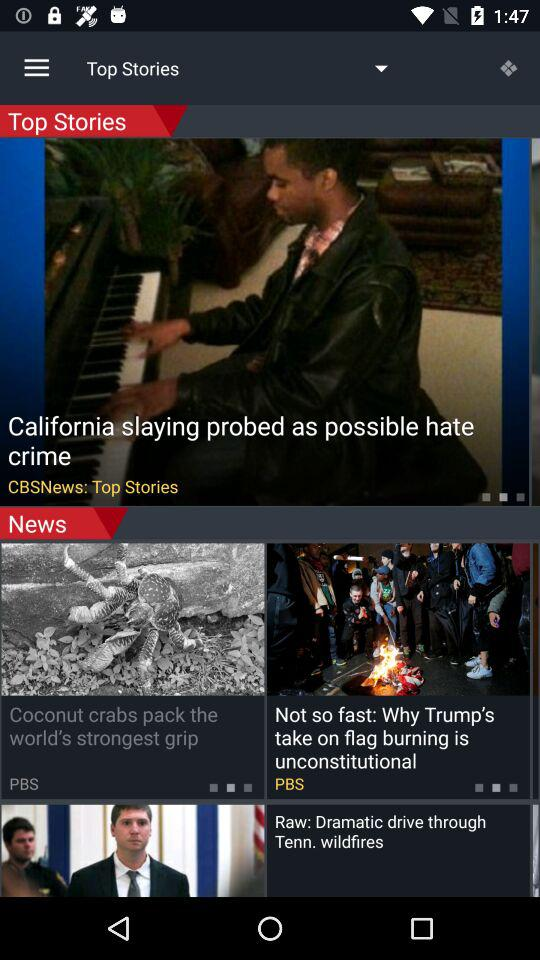How many stories are there in the news section that have a PBS logo?
Answer the question using a single word or phrase. 2 